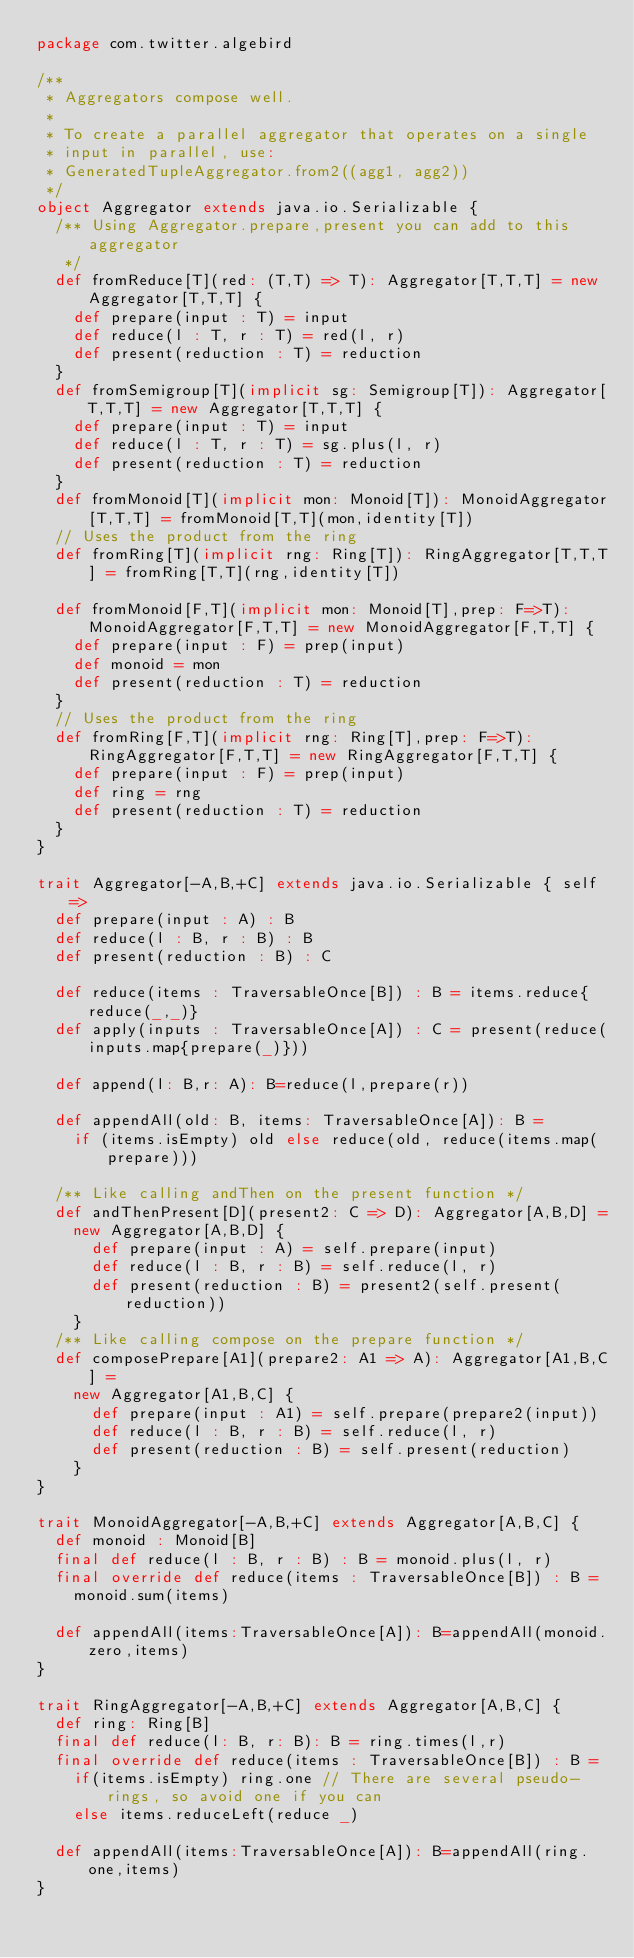<code> <loc_0><loc_0><loc_500><loc_500><_Scala_>package com.twitter.algebird

/**
 * Aggregators compose well.
 *
 * To create a parallel aggregator that operates on a single
 * input in parallel, use:
 * GeneratedTupleAggregator.from2((agg1, agg2))
 */
object Aggregator extends java.io.Serializable {
  /** Using Aggregator.prepare,present you can add to this aggregator
   */
  def fromReduce[T](red: (T,T) => T): Aggregator[T,T,T] = new Aggregator[T,T,T] {
    def prepare(input : T) = input
    def reduce(l : T, r : T) = red(l, r)
    def present(reduction : T) = reduction
  }
  def fromSemigroup[T](implicit sg: Semigroup[T]): Aggregator[T,T,T] = new Aggregator[T,T,T] {
    def prepare(input : T) = input
    def reduce(l : T, r : T) = sg.plus(l, r)
    def present(reduction : T) = reduction
  }
  def fromMonoid[T](implicit mon: Monoid[T]): MonoidAggregator[T,T,T] = fromMonoid[T,T](mon,identity[T])
  // Uses the product from the ring
  def fromRing[T](implicit rng: Ring[T]): RingAggregator[T,T,T] = fromRing[T,T](rng,identity[T])

  def fromMonoid[F,T](implicit mon: Monoid[T],prep: F=>T): MonoidAggregator[F,T,T] = new MonoidAggregator[F,T,T] {
    def prepare(input : F) = prep(input)
    def monoid = mon
    def present(reduction : T) = reduction
  }
  // Uses the product from the ring
  def fromRing[F,T](implicit rng: Ring[T],prep: F=>T): RingAggregator[F,T,T] = new RingAggregator[F,T,T] {
    def prepare(input : F) = prep(input)
    def ring = rng
    def present(reduction : T) = reduction
  }
}

trait Aggregator[-A,B,+C] extends java.io.Serializable { self =>
  def prepare(input : A) : B
  def reduce(l : B, r : B) : B
  def present(reduction : B) : C

  def reduce(items : TraversableOnce[B]) : B = items.reduce{reduce(_,_)}
  def apply(inputs : TraversableOnce[A]) : C = present(reduce(inputs.map{prepare(_)}))

  def append(l: B,r: A): B=reduce(l,prepare(r))

  def appendAll(old: B, items: TraversableOnce[A]): B =
    if (items.isEmpty) old else reduce(old, reduce(items.map(prepare)))

  /** Like calling andThen on the present function */
  def andThenPresent[D](present2: C => D): Aggregator[A,B,D] =
    new Aggregator[A,B,D] {
      def prepare(input : A) = self.prepare(input)
      def reduce(l : B, r : B) = self.reduce(l, r)
      def present(reduction : B) = present2(self.present(reduction))
    }
  /** Like calling compose on the prepare function */
  def composePrepare[A1](prepare2: A1 => A): Aggregator[A1,B,C] =
    new Aggregator[A1,B,C] {
      def prepare(input : A1) = self.prepare(prepare2(input))
      def reduce(l : B, r : B) = self.reduce(l, r)
      def present(reduction : B) = self.present(reduction)
    }
}

trait MonoidAggregator[-A,B,+C] extends Aggregator[A,B,C] {
  def monoid : Monoid[B]
  final def reduce(l : B, r : B) : B = monoid.plus(l, r)
  final override def reduce(items : TraversableOnce[B]) : B =
    monoid.sum(items)

  def appendAll(items:TraversableOnce[A]): B=appendAll(monoid.zero,items)
}

trait RingAggregator[-A,B,+C] extends Aggregator[A,B,C] {
  def ring: Ring[B]
  final def reduce(l: B, r: B): B = ring.times(l,r)
  final override def reduce(items : TraversableOnce[B]) : B =
    if(items.isEmpty) ring.one // There are several pseudo-rings, so avoid one if you can
    else items.reduceLeft(reduce _)

  def appendAll(items:TraversableOnce[A]): B=appendAll(ring.one,items)
}
</code> 